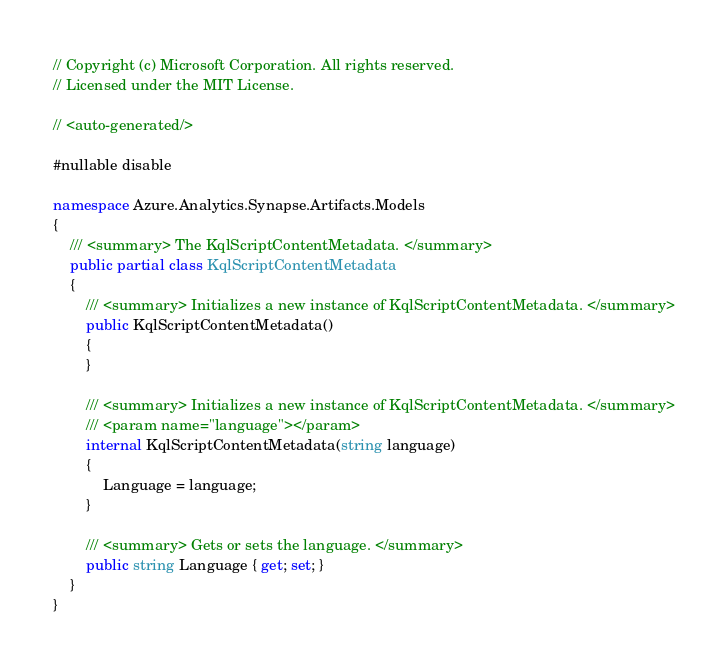Convert code to text. <code><loc_0><loc_0><loc_500><loc_500><_C#_>// Copyright (c) Microsoft Corporation. All rights reserved.
// Licensed under the MIT License.

// <auto-generated/>

#nullable disable

namespace Azure.Analytics.Synapse.Artifacts.Models
{
    /// <summary> The KqlScriptContentMetadata. </summary>
    public partial class KqlScriptContentMetadata
    {
        /// <summary> Initializes a new instance of KqlScriptContentMetadata. </summary>
        public KqlScriptContentMetadata()
        {
        }

        /// <summary> Initializes a new instance of KqlScriptContentMetadata. </summary>
        /// <param name="language"></param>
        internal KqlScriptContentMetadata(string language)
        {
            Language = language;
        }

        /// <summary> Gets or sets the language. </summary>
        public string Language { get; set; }
    }
}
</code> 